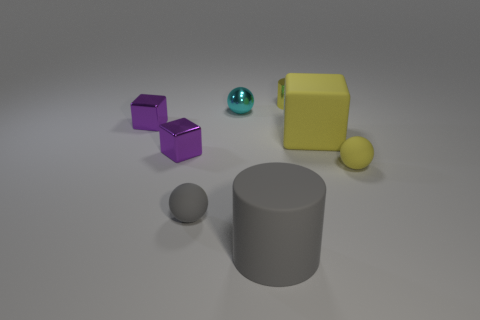Subtract all matte spheres. How many spheres are left? 1 Subtract all gray spheres. How many purple cubes are left? 2 Subtract all yellow cubes. How many cubes are left? 2 Subtract 1 spheres. How many spheres are left? 2 Add 1 matte blocks. How many objects exist? 9 Subtract all cylinders. How many objects are left? 6 Subtract all blue blocks. Subtract all brown cylinders. How many blocks are left? 3 Add 4 small cyan metallic balls. How many small cyan metallic balls exist? 5 Subtract 0 purple spheres. How many objects are left? 8 Subtract all yellow metallic cylinders. Subtract all small purple cubes. How many objects are left? 5 